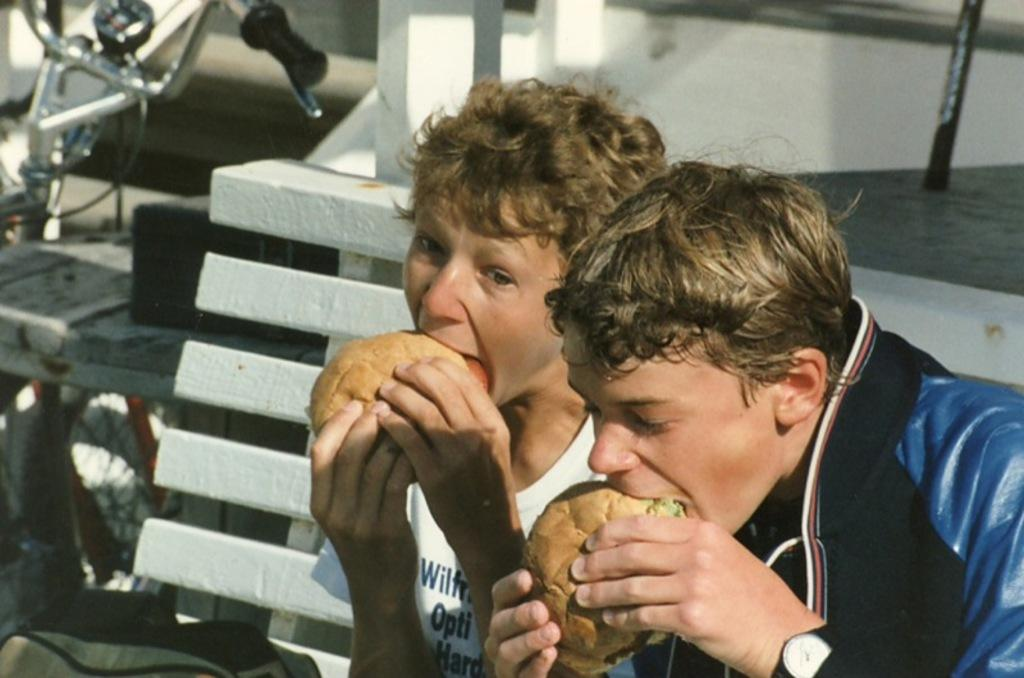How many people are in the image? There are two people in the image. What are the people doing in the image? The people are eating burgers. Where are the people sitting in the image? The people are sitting on a bench. What can be seen at the bottom of the image? There is a bag at the bottom of the image. What is visible in the background of the image? There is a bicycle and a floor visible in the background of the image. What type of cloth is being used to cover the cub in the image? There is no cub or cloth present in the image. How does the regret of the people eating burgers affect the atmosphere in the image? There is no indication of regret in the image, as the people are enjoying their burgers. 